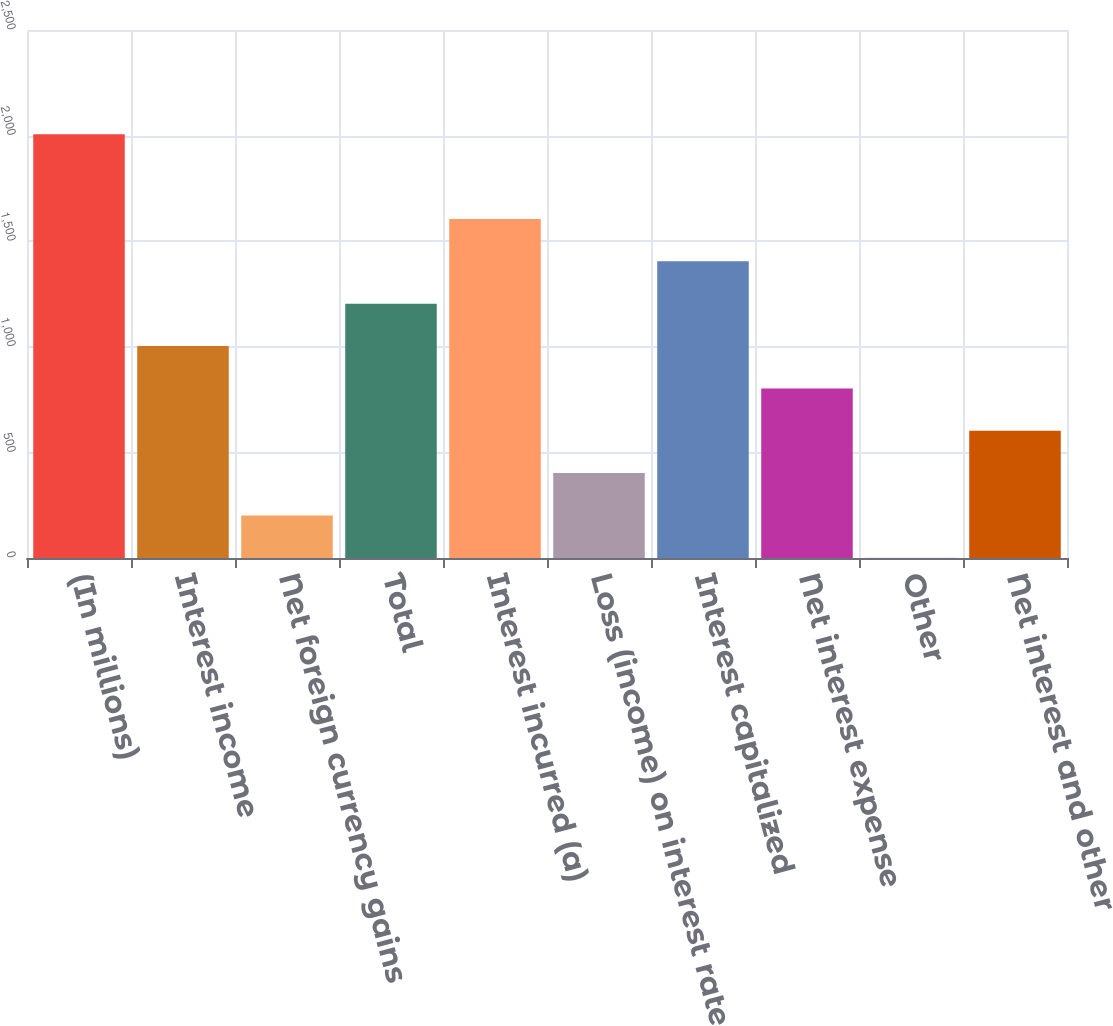<chart> <loc_0><loc_0><loc_500><loc_500><bar_chart><fcel>(In millions)<fcel>Interest income<fcel>Net foreign currency gains<fcel>Total<fcel>Interest incurred (a)<fcel>Loss (income) on interest rate<fcel>Interest capitalized<fcel>Net interest expense<fcel>Other<fcel>Net interest and other<nl><fcel>2006<fcel>1003.5<fcel>201.5<fcel>1204<fcel>1605<fcel>402<fcel>1404.5<fcel>803<fcel>1<fcel>602.5<nl></chart> 